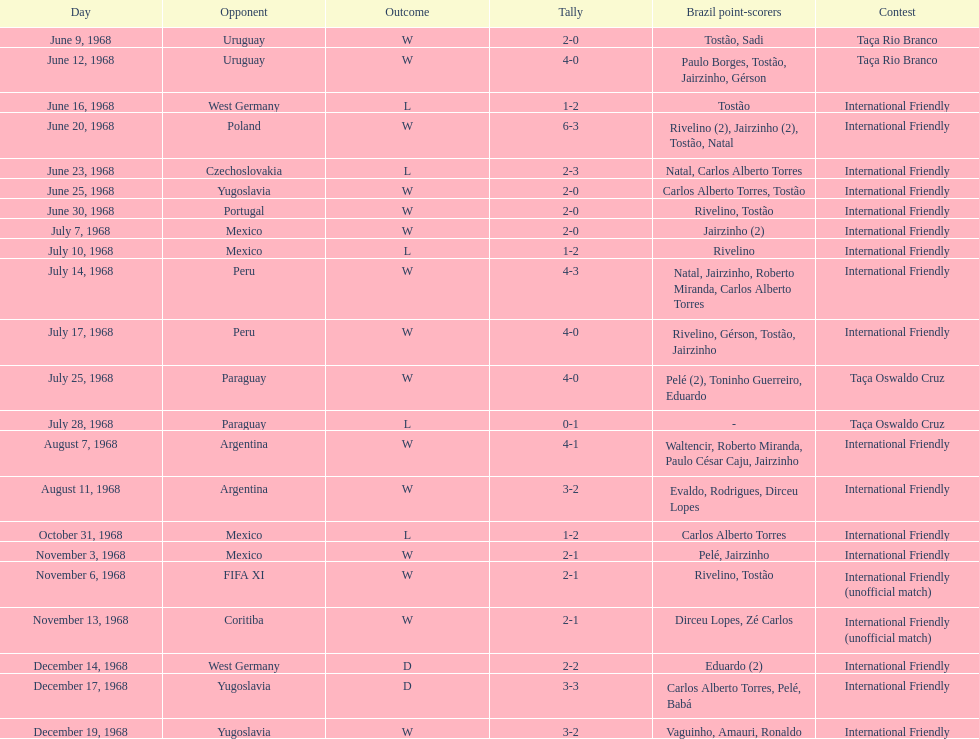How many times did brazil play against argentina in the international friendly competition? 2. 